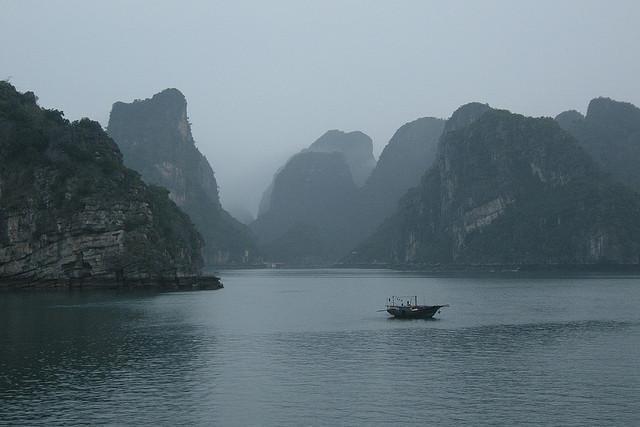How many train cars are seen in this picture?
Give a very brief answer. 0. 